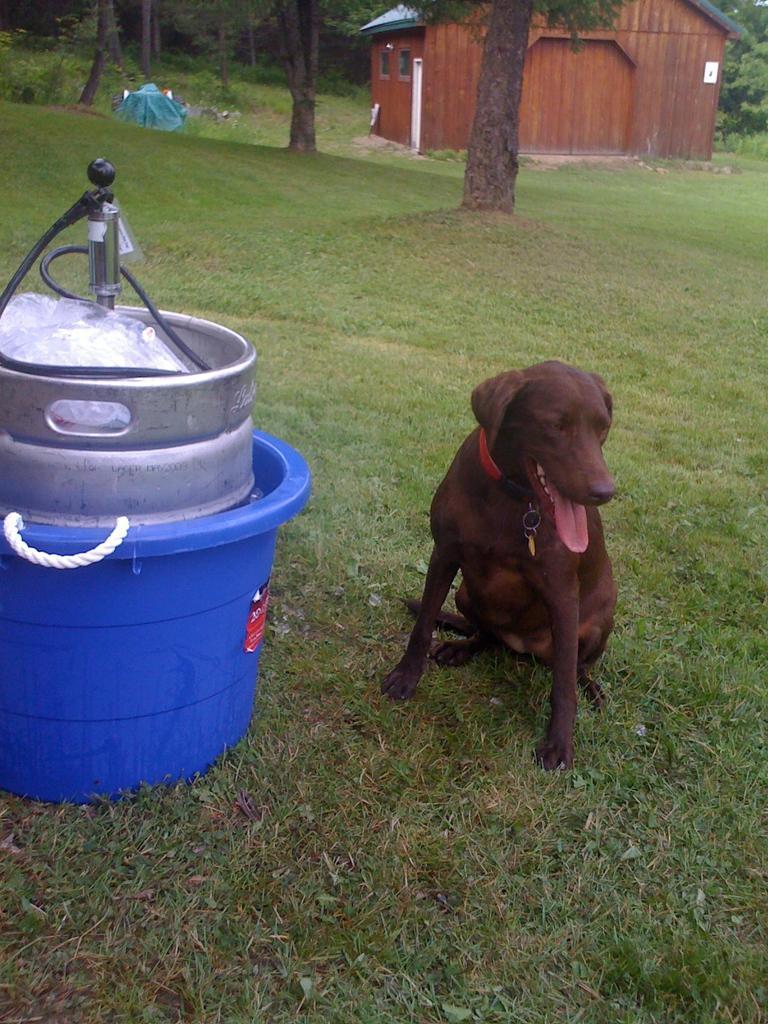Please provide a concise description of this image. In this image, I can see a dog on the grass. On the left side of the image, there is an object in a tub. In the background, I can see a house and the trees. 